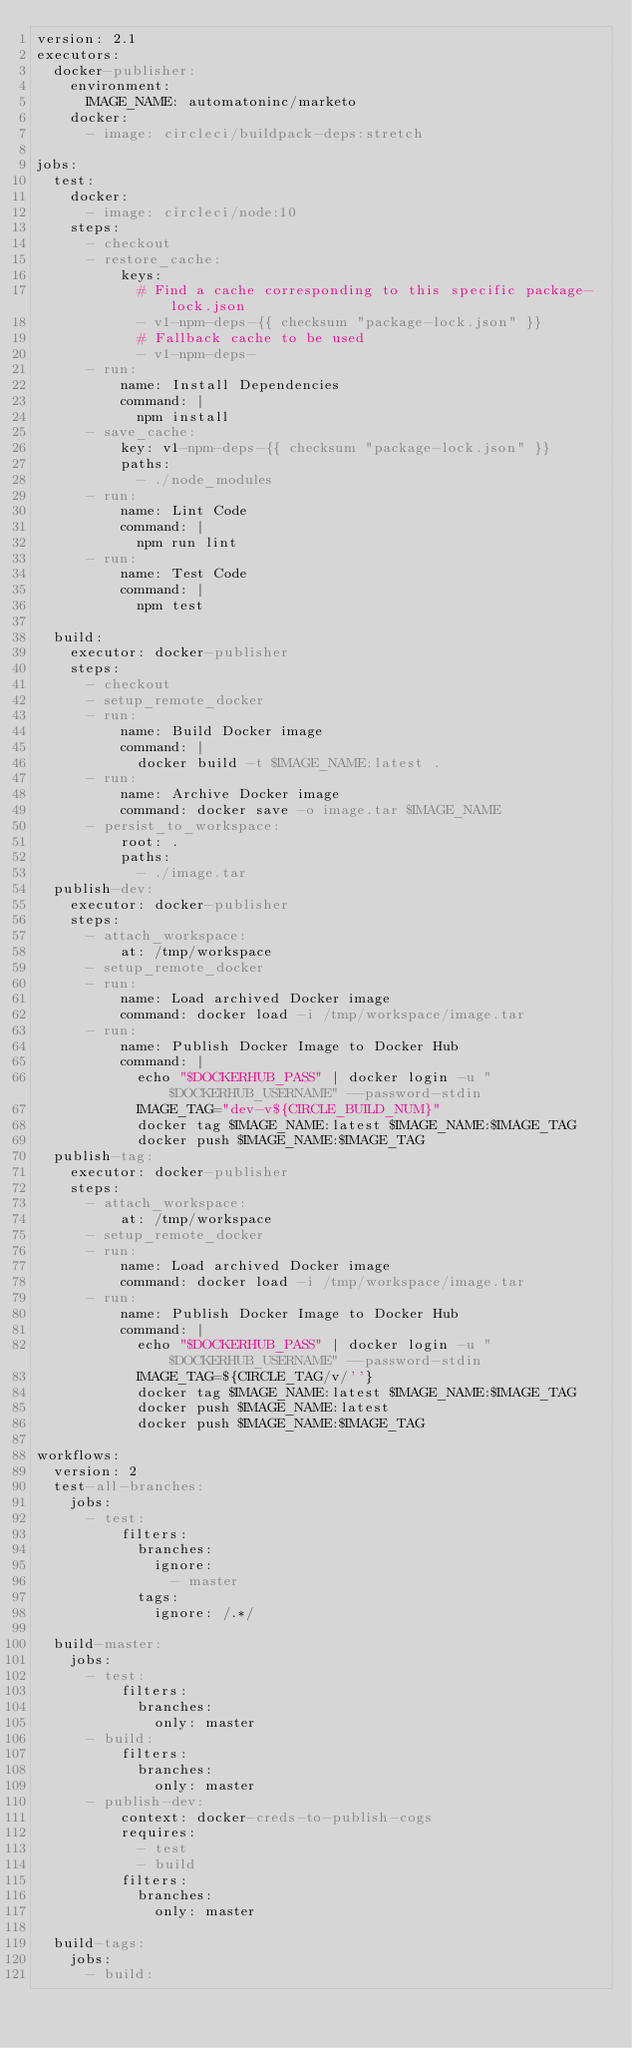<code> <loc_0><loc_0><loc_500><loc_500><_YAML_>version: 2.1
executors:
  docker-publisher:
    environment:
      IMAGE_NAME: automatoninc/marketo
    docker:
      - image: circleci/buildpack-deps:stretch

jobs:
  test:
    docker:
      - image: circleci/node:10
    steps:
      - checkout
      - restore_cache:
          keys:
            # Find a cache corresponding to this specific package-lock.json
            - v1-npm-deps-{{ checksum "package-lock.json" }}
            # Fallback cache to be used
            - v1-npm-deps-
      - run:
          name: Install Dependencies
          command: |
            npm install
      - save_cache:
          key: v1-npm-deps-{{ checksum "package-lock.json" }}
          paths:
            - ./node_modules
      - run:
          name: Lint Code
          command: |
            npm run lint
      - run:
          name: Test Code
          command: |
            npm test

  build:
    executor: docker-publisher
    steps:
      - checkout
      - setup_remote_docker
      - run:
          name: Build Docker image
          command: |
            docker build -t $IMAGE_NAME:latest .
      - run:
          name: Archive Docker image
          command: docker save -o image.tar $IMAGE_NAME
      - persist_to_workspace:
          root: .
          paths:
            - ./image.tar
  publish-dev:
    executor: docker-publisher
    steps:
      - attach_workspace:
          at: /tmp/workspace
      - setup_remote_docker
      - run:
          name: Load archived Docker image
          command: docker load -i /tmp/workspace/image.tar
      - run:
          name: Publish Docker Image to Docker Hub
          command: |
            echo "$DOCKERHUB_PASS" | docker login -u "$DOCKERHUB_USERNAME" --password-stdin
            IMAGE_TAG="dev-v${CIRCLE_BUILD_NUM}"
            docker tag $IMAGE_NAME:latest $IMAGE_NAME:$IMAGE_TAG
            docker push $IMAGE_NAME:$IMAGE_TAG
  publish-tag:
    executor: docker-publisher
    steps:
      - attach_workspace:
          at: /tmp/workspace
      - setup_remote_docker
      - run:
          name: Load archived Docker image
          command: docker load -i /tmp/workspace/image.tar
      - run:
          name: Publish Docker Image to Docker Hub
          command: |
            echo "$DOCKERHUB_PASS" | docker login -u "$DOCKERHUB_USERNAME" --password-stdin
            IMAGE_TAG=${CIRCLE_TAG/v/''}
            docker tag $IMAGE_NAME:latest $IMAGE_NAME:$IMAGE_TAG
            docker push $IMAGE_NAME:latest
            docker push $IMAGE_NAME:$IMAGE_TAG

workflows:
  version: 2
  test-all-branches:
    jobs:
      - test:
          filters:
            branches:
              ignore:
                - master
            tags:
              ignore: /.*/

  build-master:
    jobs:
      - test:
          filters:
            branches:
              only: master
      - build:
          filters:
            branches:
              only: master
      - publish-dev:
          context: docker-creds-to-publish-cogs
          requires:
            - test
            - build
          filters:
            branches:
              only: master

  build-tags:
    jobs:
      - build:</code> 